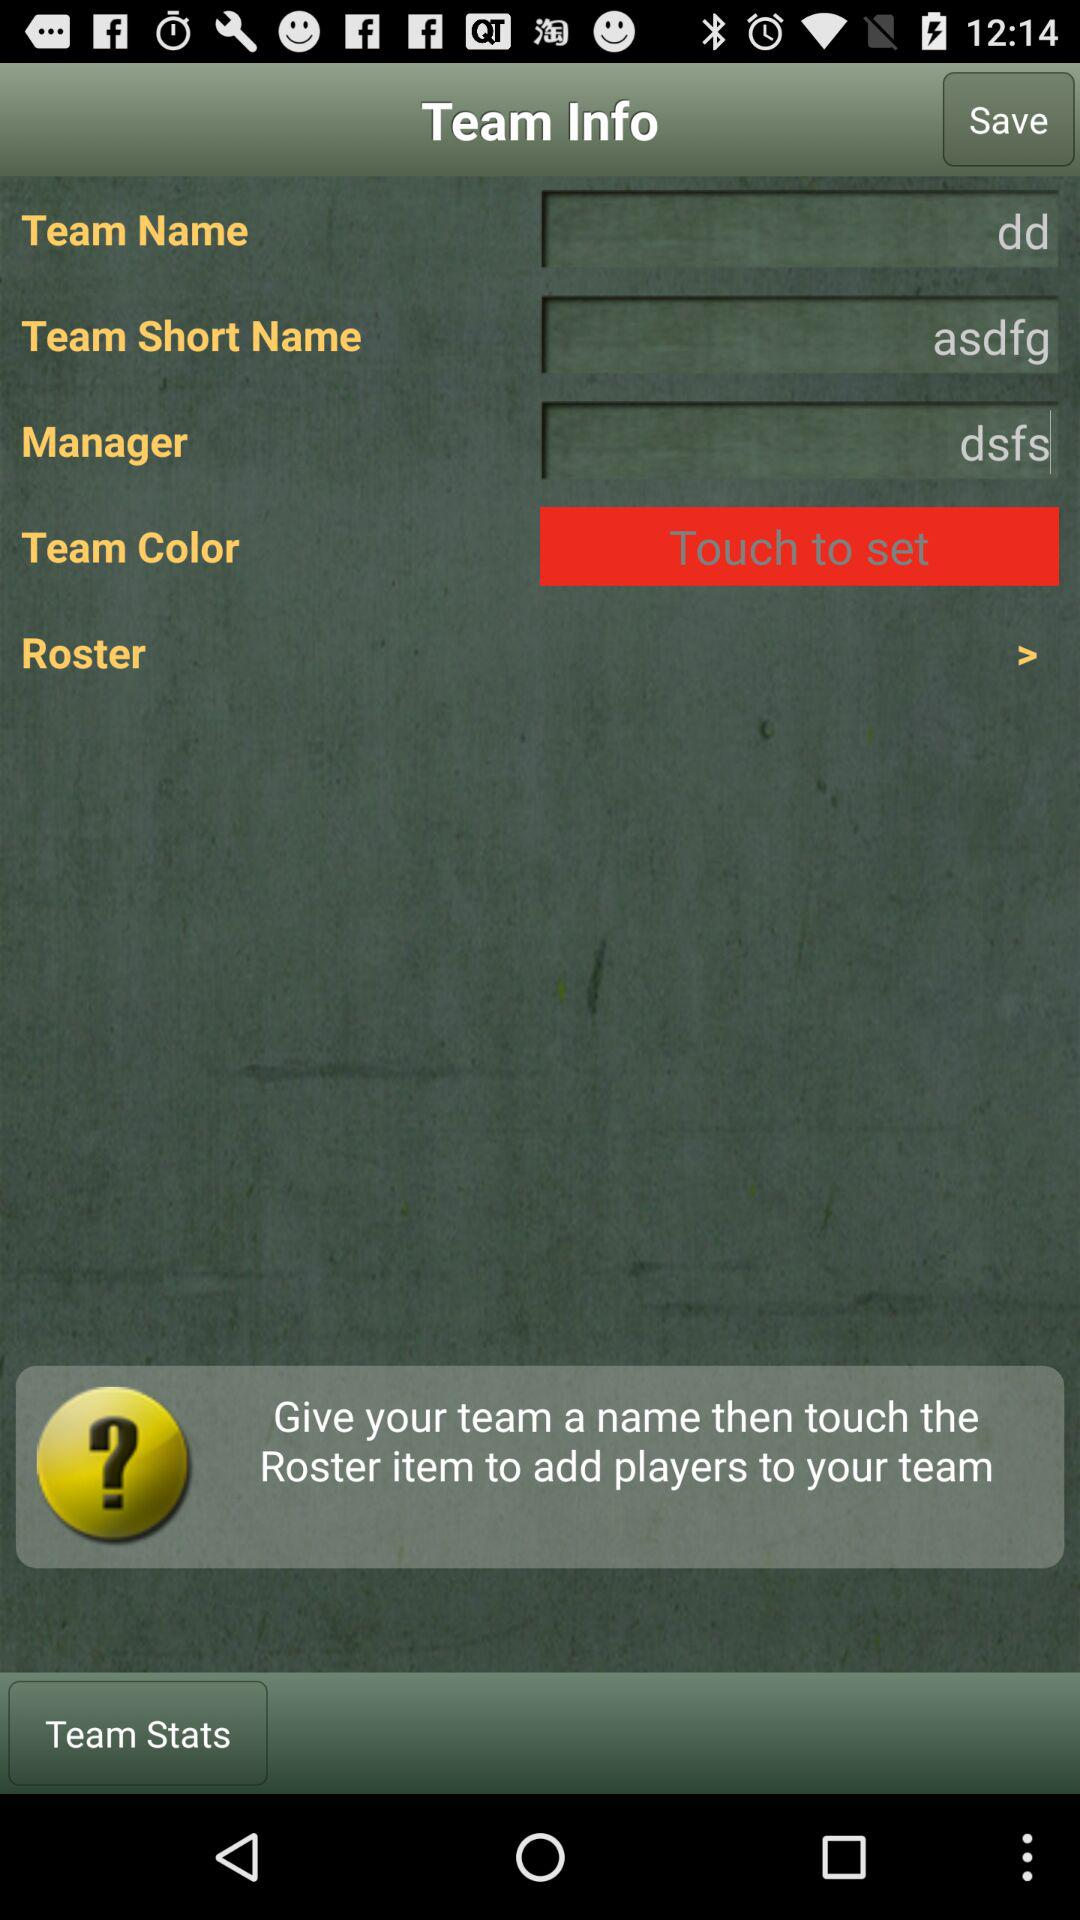What is the name of the manager? The name of the manager is "dsfs". 